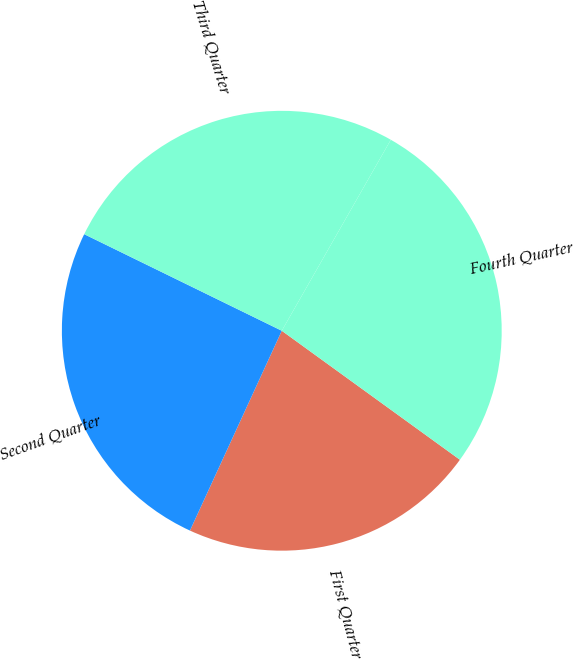<chart> <loc_0><loc_0><loc_500><loc_500><pie_chart><fcel>First Quarter<fcel>Second Quarter<fcel>Third Quarter<fcel>Fourth Quarter<nl><fcel>21.88%<fcel>25.38%<fcel>26.02%<fcel>26.72%<nl></chart> 